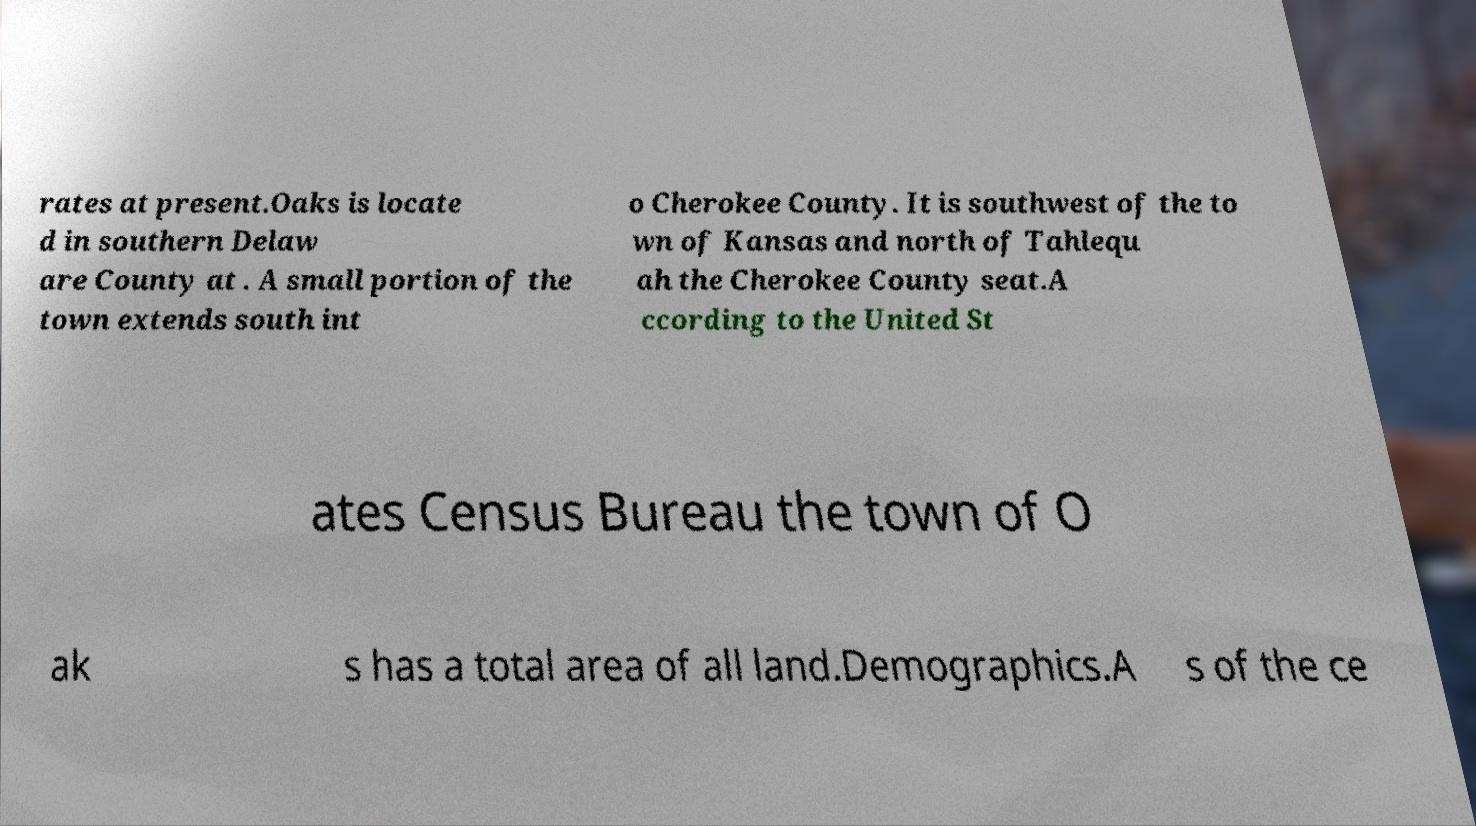There's text embedded in this image that I need extracted. Can you transcribe it verbatim? rates at present.Oaks is locate d in southern Delaw are County at . A small portion of the town extends south int o Cherokee County. It is southwest of the to wn of Kansas and north of Tahlequ ah the Cherokee County seat.A ccording to the United St ates Census Bureau the town of O ak s has a total area of all land.Demographics.A s of the ce 